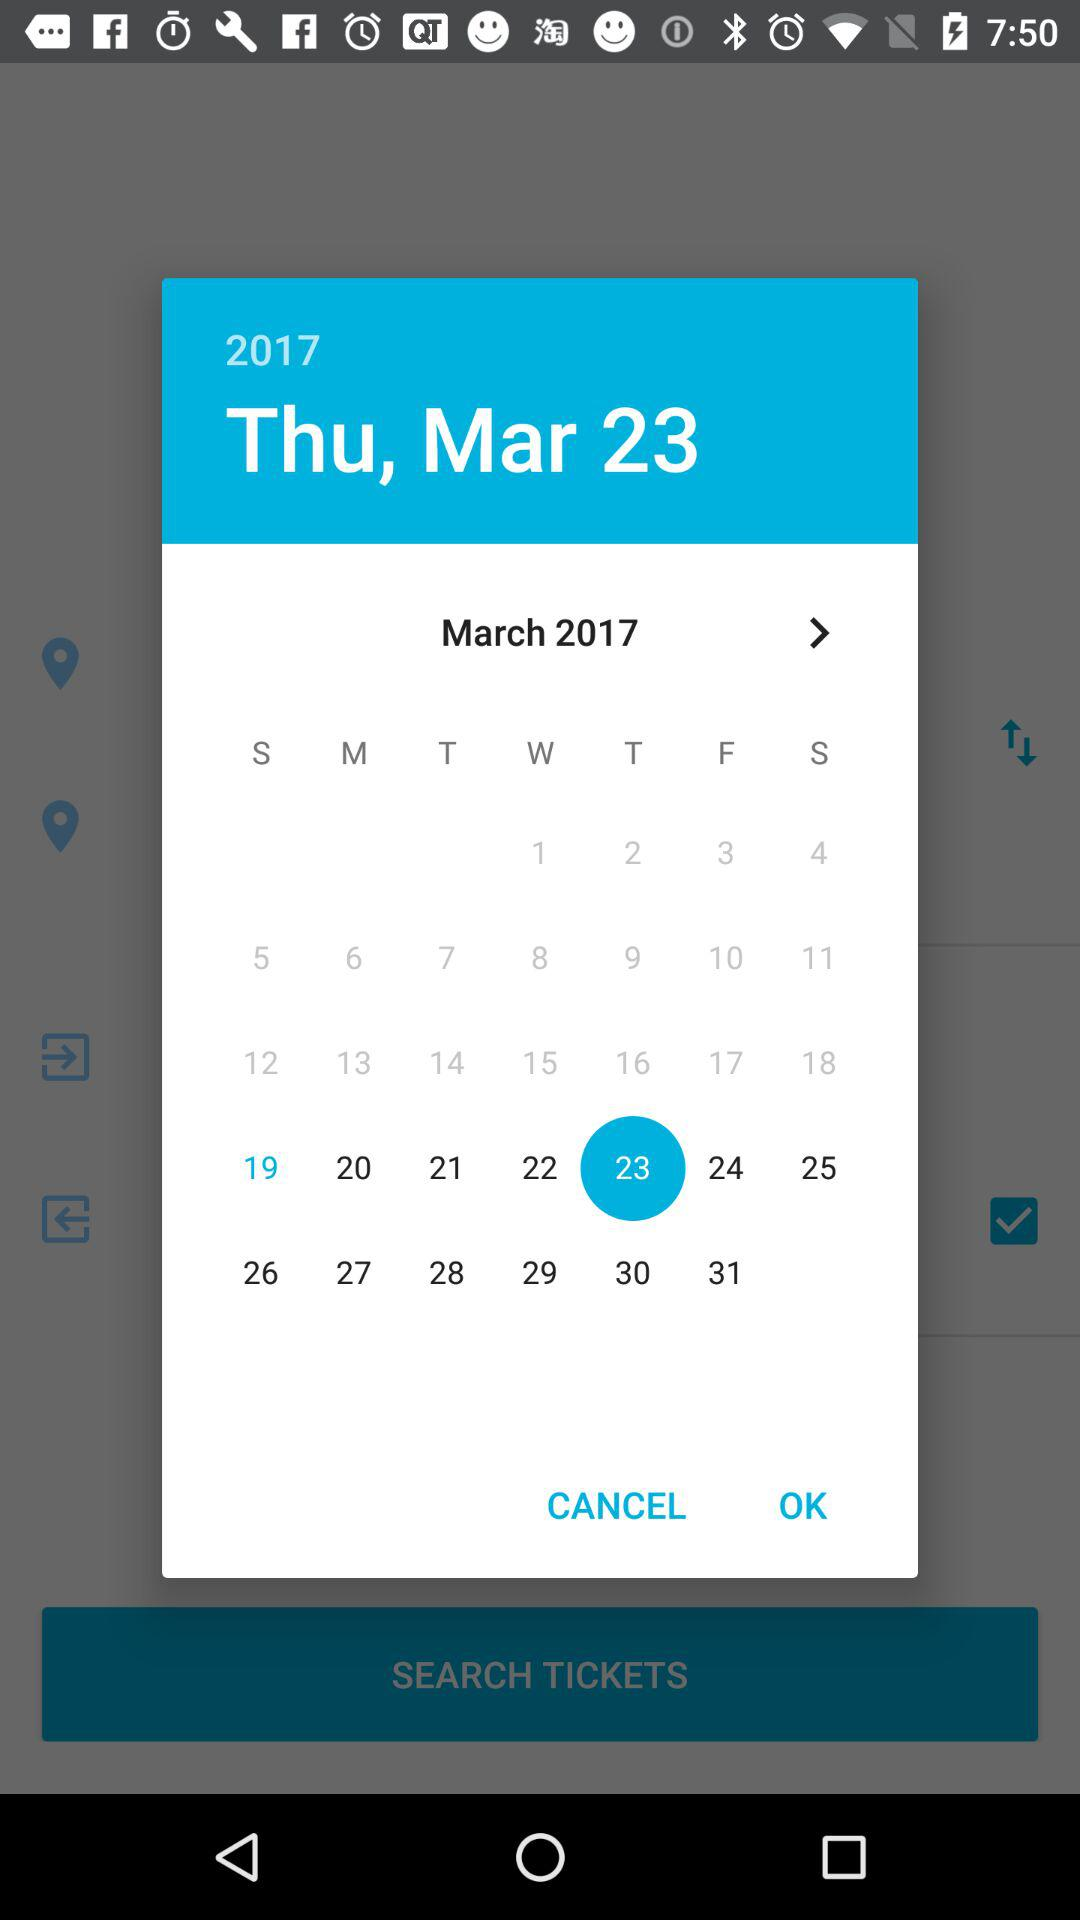Which day falls on March 23, 2017? The day is Thursday. 